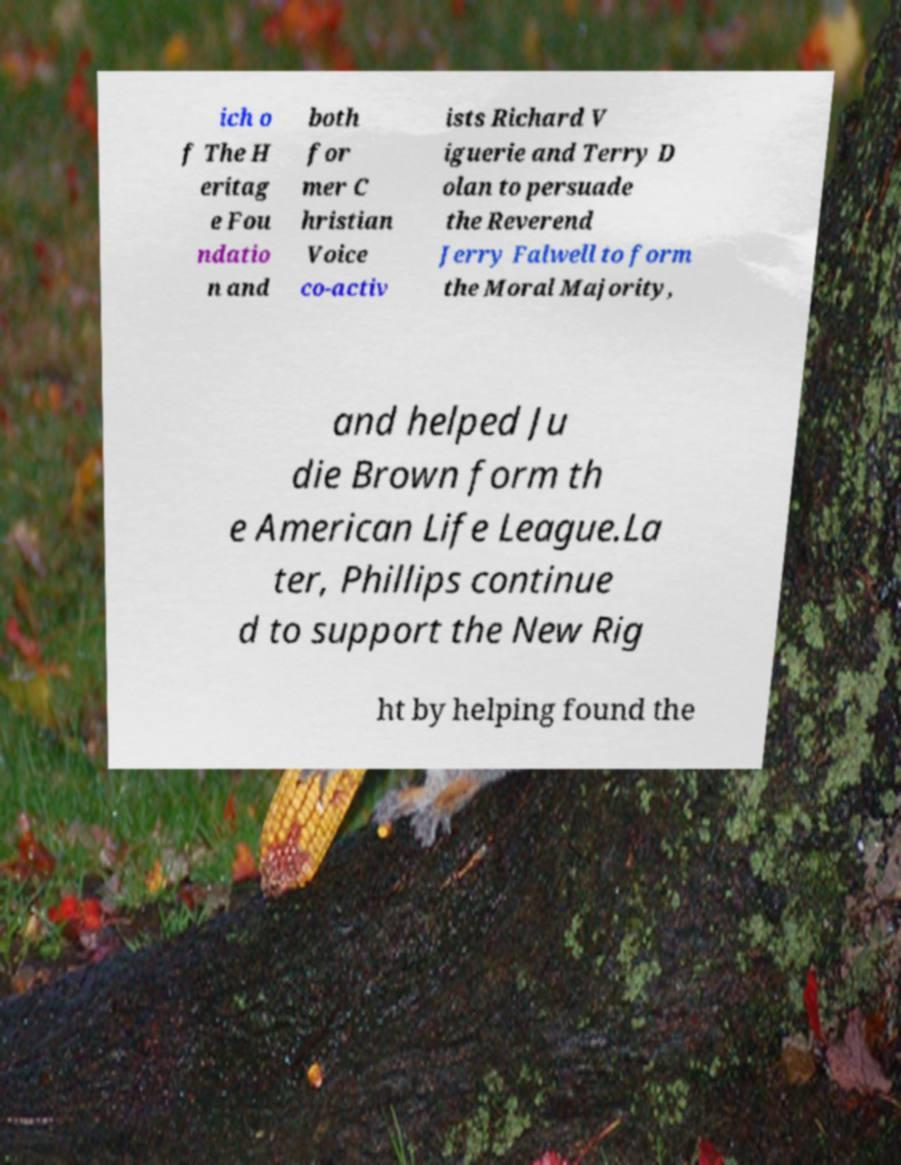Could you extract and type out the text from this image? ich o f The H eritag e Fou ndatio n and both for mer C hristian Voice co-activ ists Richard V iguerie and Terry D olan to persuade the Reverend Jerry Falwell to form the Moral Majority, and helped Ju die Brown form th e American Life League.La ter, Phillips continue d to support the New Rig ht by helping found the 